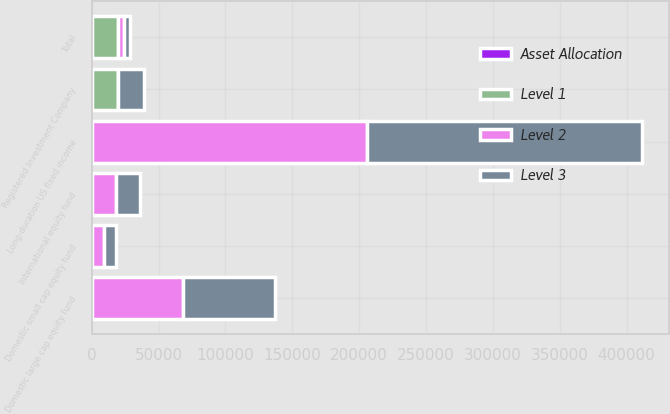Convert chart to OTSL. <chart><loc_0><loc_0><loc_500><loc_500><stacked_bar_chart><ecel><fcel>Long-duration US fixed income<fcel>Registered Investment Company<fcel>International equity fund<fcel>Domestic large cap equity fund<fcel>Domestic small cap equity fund<fcel>Total<nl><fcel>Level 1<fcel>0<fcel>19400<fcel>0<fcel>0<fcel>0<fcel>19400<nl><fcel>Level 2<fcel>205695<fcel>0<fcel>18062<fcel>68624<fcel>9207<fcel>4603.5<nl><fcel>Asset Allocation<fcel>0<fcel>0<fcel>0<fcel>0<fcel>0<fcel>0<nl><fcel>Level 3<fcel>205695<fcel>19400<fcel>18062<fcel>68624<fcel>9207<fcel>4603.5<nl></chart> 